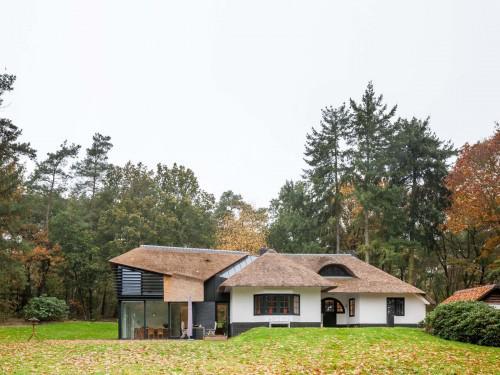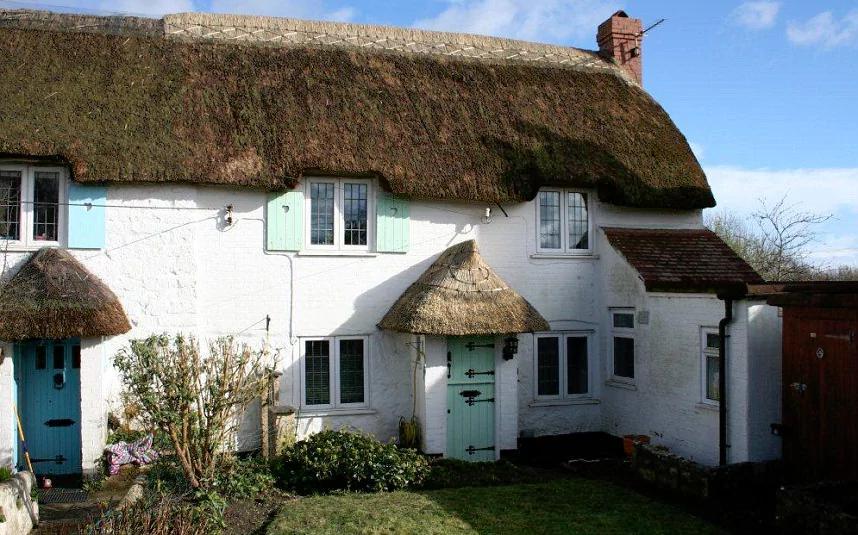The first image is the image on the left, the second image is the image on the right. For the images shown, is this caption "The right image is a head-on view of a white building with at least two notches in the roofline to accommodate upper story windows and at least one pyramid roof shape projecting at the front of the house." true? Answer yes or no. Yes. 